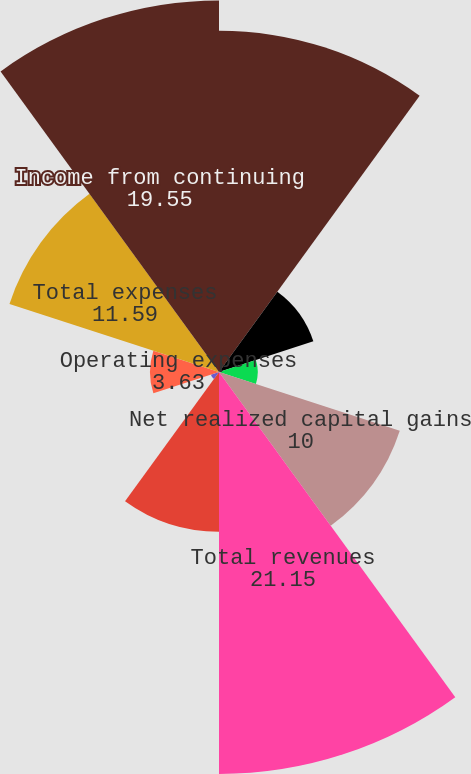<chart> <loc_0><loc_0><loc_500><loc_500><pie_chart><fcel>Premiums and other<fcel>Fees and other revenues<fcel>Net investment income<fcel>Net realized capital gains<fcel>Total revenues<fcel>Benefits claims and settlement<fcel>Dividends to policyholders<fcel>Operating expenses<fcel>Total expenses<fcel>Income from continuing<nl><fcel>17.96%<fcel>5.22%<fcel>2.04%<fcel>10.0%<fcel>21.15%<fcel>8.41%<fcel>0.45%<fcel>3.63%<fcel>11.59%<fcel>19.55%<nl></chart> 